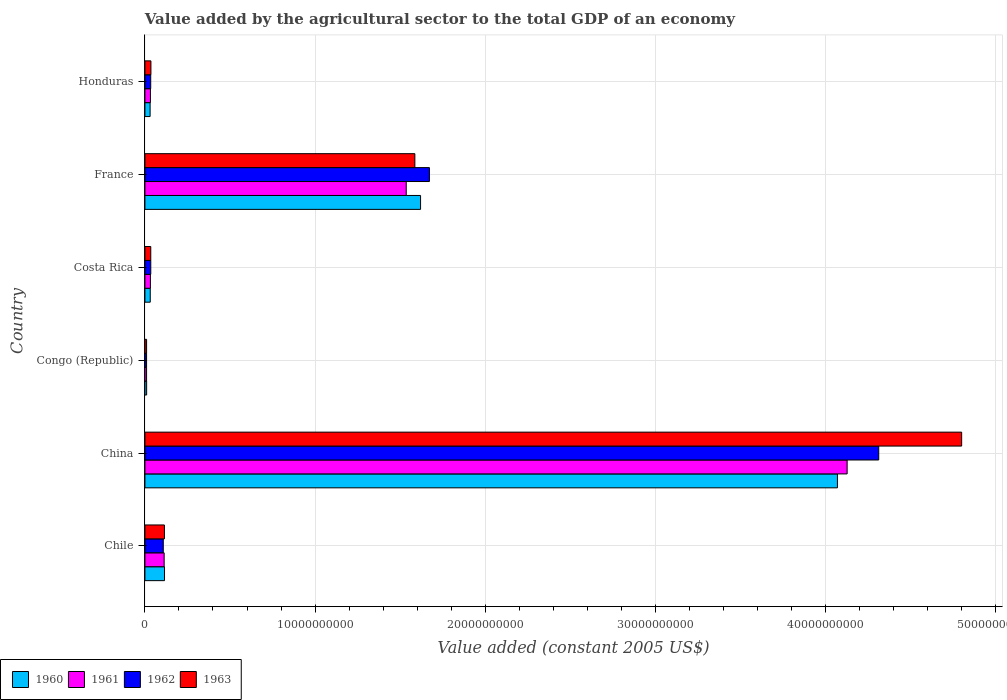How many different coloured bars are there?
Provide a succinct answer. 4. Are the number of bars per tick equal to the number of legend labels?
Offer a terse response. Yes. What is the label of the 5th group of bars from the top?
Your answer should be compact. China. In how many cases, is the number of bars for a given country not equal to the number of legend labels?
Offer a terse response. 0. What is the value added by the agricultural sector in 1963 in Congo (Republic)?
Ensure brevity in your answer.  9.86e+07. Across all countries, what is the maximum value added by the agricultural sector in 1963?
Provide a succinct answer. 4.80e+1. Across all countries, what is the minimum value added by the agricultural sector in 1961?
Your answer should be very brief. 9.74e+07. In which country was the value added by the agricultural sector in 1963 maximum?
Ensure brevity in your answer.  China. In which country was the value added by the agricultural sector in 1963 minimum?
Make the answer very short. Congo (Republic). What is the total value added by the agricultural sector in 1962 in the graph?
Give a very brief answer. 6.17e+1. What is the difference between the value added by the agricultural sector in 1963 in Chile and that in France?
Give a very brief answer. -1.47e+1. What is the difference between the value added by the agricultural sector in 1963 in France and the value added by the agricultural sector in 1962 in Honduras?
Provide a succinct answer. 1.55e+1. What is the average value added by the agricultural sector in 1963 per country?
Provide a short and direct response. 1.10e+1. What is the difference between the value added by the agricultural sector in 1961 and value added by the agricultural sector in 1960 in Costa Rica?
Provide a short and direct response. 1.15e+07. In how many countries, is the value added by the agricultural sector in 1960 greater than 26000000000 US$?
Offer a terse response. 1. What is the ratio of the value added by the agricultural sector in 1963 in Costa Rica to that in France?
Ensure brevity in your answer.  0.02. Is the difference between the value added by the agricultural sector in 1961 in Costa Rica and Honduras greater than the difference between the value added by the agricultural sector in 1960 in Costa Rica and Honduras?
Provide a short and direct response. No. What is the difference between the highest and the second highest value added by the agricultural sector in 1962?
Provide a short and direct response. 2.64e+1. What is the difference between the highest and the lowest value added by the agricultural sector in 1961?
Provide a short and direct response. 4.12e+1. Is the sum of the value added by the agricultural sector in 1962 in China and Congo (Republic) greater than the maximum value added by the agricultural sector in 1963 across all countries?
Offer a terse response. No. Are all the bars in the graph horizontal?
Ensure brevity in your answer.  Yes. How many countries are there in the graph?
Ensure brevity in your answer.  6. How many legend labels are there?
Make the answer very short. 4. What is the title of the graph?
Your answer should be compact. Value added by the agricultural sector to the total GDP of an economy. Does "1986" appear as one of the legend labels in the graph?
Provide a short and direct response. No. What is the label or title of the X-axis?
Keep it short and to the point. Value added (constant 2005 US$). What is the Value added (constant 2005 US$) of 1960 in Chile?
Offer a very short reply. 1.15e+09. What is the Value added (constant 2005 US$) of 1961 in Chile?
Provide a short and direct response. 1.13e+09. What is the Value added (constant 2005 US$) in 1962 in Chile?
Give a very brief answer. 1.08e+09. What is the Value added (constant 2005 US$) in 1963 in Chile?
Give a very brief answer. 1.15e+09. What is the Value added (constant 2005 US$) of 1960 in China?
Your response must be concise. 4.07e+1. What is the Value added (constant 2005 US$) of 1961 in China?
Offer a terse response. 4.13e+1. What is the Value added (constant 2005 US$) of 1962 in China?
Offer a terse response. 4.31e+1. What is the Value added (constant 2005 US$) of 1963 in China?
Give a very brief answer. 4.80e+1. What is the Value added (constant 2005 US$) in 1960 in Congo (Republic)?
Make the answer very short. 1.01e+08. What is the Value added (constant 2005 US$) of 1961 in Congo (Republic)?
Offer a terse response. 9.74e+07. What is the Value added (constant 2005 US$) of 1962 in Congo (Republic)?
Offer a terse response. 9.79e+07. What is the Value added (constant 2005 US$) in 1963 in Congo (Republic)?
Offer a very short reply. 9.86e+07. What is the Value added (constant 2005 US$) in 1960 in Costa Rica?
Make the answer very short. 3.13e+08. What is the Value added (constant 2005 US$) of 1961 in Costa Rica?
Offer a very short reply. 3.24e+08. What is the Value added (constant 2005 US$) of 1962 in Costa Rica?
Your answer should be very brief. 3.44e+08. What is the Value added (constant 2005 US$) of 1963 in Costa Rica?
Give a very brief answer. 3.43e+08. What is the Value added (constant 2005 US$) in 1960 in France?
Ensure brevity in your answer.  1.62e+1. What is the Value added (constant 2005 US$) in 1961 in France?
Offer a terse response. 1.54e+1. What is the Value added (constant 2005 US$) in 1962 in France?
Give a very brief answer. 1.67e+1. What is the Value added (constant 2005 US$) of 1963 in France?
Your answer should be compact. 1.59e+1. What is the Value added (constant 2005 US$) of 1960 in Honduras?
Provide a short and direct response. 3.05e+08. What is the Value added (constant 2005 US$) in 1961 in Honduras?
Provide a short and direct response. 3.25e+08. What is the Value added (constant 2005 US$) in 1962 in Honduras?
Provide a succinct answer. 3.41e+08. What is the Value added (constant 2005 US$) of 1963 in Honduras?
Keep it short and to the point. 3.53e+08. Across all countries, what is the maximum Value added (constant 2005 US$) of 1960?
Your answer should be compact. 4.07e+1. Across all countries, what is the maximum Value added (constant 2005 US$) of 1961?
Keep it short and to the point. 4.13e+1. Across all countries, what is the maximum Value added (constant 2005 US$) in 1962?
Provide a succinct answer. 4.31e+1. Across all countries, what is the maximum Value added (constant 2005 US$) of 1963?
Provide a succinct answer. 4.80e+1. Across all countries, what is the minimum Value added (constant 2005 US$) in 1960?
Your response must be concise. 1.01e+08. Across all countries, what is the minimum Value added (constant 2005 US$) in 1961?
Your answer should be very brief. 9.74e+07. Across all countries, what is the minimum Value added (constant 2005 US$) in 1962?
Your response must be concise. 9.79e+07. Across all countries, what is the minimum Value added (constant 2005 US$) in 1963?
Your answer should be very brief. 9.86e+07. What is the total Value added (constant 2005 US$) in 1960 in the graph?
Provide a short and direct response. 5.88e+1. What is the total Value added (constant 2005 US$) of 1961 in the graph?
Your answer should be very brief. 5.85e+1. What is the total Value added (constant 2005 US$) of 1962 in the graph?
Ensure brevity in your answer.  6.17e+1. What is the total Value added (constant 2005 US$) in 1963 in the graph?
Ensure brevity in your answer.  6.58e+1. What is the difference between the Value added (constant 2005 US$) in 1960 in Chile and that in China?
Provide a succinct answer. -3.95e+1. What is the difference between the Value added (constant 2005 US$) of 1961 in Chile and that in China?
Your answer should be very brief. -4.01e+1. What is the difference between the Value added (constant 2005 US$) in 1962 in Chile and that in China?
Your answer should be very brief. -4.20e+1. What is the difference between the Value added (constant 2005 US$) in 1963 in Chile and that in China?
Provide a short and direct response. -4.69e+1. What is the difference between the Value added (constant 2005 US$) of 1960 in Chile and that in Congo (Republic)?
Your response must be concise. 1.05e+09. What is the difference between the Value added (constant 2005 US$) of 1961 in Chile and that in Congo (Republic)?
Keep it short and to the point. 1.03e+09. What is the difference between the Value added (constant 2005 US$) of 1962 in Chile and that in Congo (Republic)?
Offer a terse response. 9.81e+08. What is the difference between the Value added (constant 2005 US$) of 1963 in Chile and that in Congo (Republic)?
Give a very brief answer. 1.05e+09. What is the difference between the Value added (constant 2005 US$) in 1960 in Chile and that in Costa Rica?
Offer a very short reply. 8.39e+08. What is the difference between the Value added (constant 2005 US$) of 1961 in Chile and that in Costa Rica?
Ensure brevity in your answer.  8.06e+08. What is the difference between the Value added (constant 2005 US$) in 1962 in Chile and that in Costa Rica?
Provide a succinct answer. 7.35e+08. What is the difference between the Value added (constant 2005 US$) of 1963 in Chile and that in Costa Rica?
Your answer should be compact. 8.03e+08. What is the difference between the Value added (constant 2005 US$) of 1960 in Chile and that in France?
Keep it short and to the point. -1.50e+1. What is the difference between the Value added (constant 2005 US$) in 1961 in Chile and that in France?
Give a very brief answer. -1.42e+1. What is the difference between the Value added (constant 2005 US$) in 1962 in Chile and that in France?
Your answer should be compact. -1.56e+1. What is the difference between the Value added (constant 2005 US$) of 1963 in Chile and that in France?
Provide a short and direct response. -1.47e+1. What is the difference between the Value added (constant 2005 US$) of 1960 in Chile and that in Honduras?
Provide a short and direct response. 8.46e+08. What is the difference between the Value added (constant 2005 US$) in 1961 in Chile and that in Honduras?
Provide a succinct answer. 8.05e+08. What is the difference between the Value added (constant 2005 US$) in 1962 in Chile and that in Honduras?
Give a very brief answer. 7.38e+08. What is the difference between the Value added (constant 2005 US$) in 1963 in Chile and that in Honduras?
Offer a terse response. 7.93e+08. What is the difference between the Value added (constant 2005 US$) in 1960 in China and that in Congo (Republic)?
Give a very brief answer. 4.06e+1. What is the difference between the Value added (constant 2005 US$) in 1961 in China and that in Congo (Republic)?
Give a very brief answer. 4.12e+1. What is the difference between the Value added (constant 2005 US$) in 1962 in China and that in Congo (Republic)?
Offer a very short reply. 4.30e+1. What is the difference between the Value added (constant 2005 US$) of 1963 in China and that in Congo (Republic)?
Provide a short and direct response. 4.79e+1. What is the difference between the Value added (constant 2005 US$) of 1960 in China and that in Costa Rica?
Provide a succinct answer. 4.04e+1. What is the difference between the Value added (constant 2005 US$) in 1961 in China and that in Costa Rica?
Provide a succinct answer. 4.09e+1. What is the difference between the Value added (constant 2005 US$) of 1962 in China and that in Costa Rica?
Ensure brevity in your answer.  4.28e+1. What is the difference between the Value added (constant 2005 US$) in 1963 in China and that in Costa Rica?
Ensure brevity in your answer.  4.77e+1. What is the difference between the Value added (constant 2005 US$) of 1960 in China and that in France?
Provide a short and direct response. 2.45e+1. What is the difference between the Value added (constant 2005 US$) in 1961 in China and that in France?
Give a very brief answer. 2.59e+1. What is the difference between the Value added (constant 2005 US$) in 1962 in China and that in France?
Provide a succinct answer. 2.64e+1. What is the difference between the Value added (constant 2005 US$) in 1963 in China and that in France?
Offer a very short reply. 3.21e+1. What is the difference between the Value added (constant 2005 US$) in 1960 in China and that in Honduras?
Keep it short and to the point. 4.04e+1. What is the difference between the Value added (constant 2005 US$) of 1961 in China and that in Honduras?
Ensure brevity in your answer.  4.09e+1. What is the difference between the Value added (constant 2005 US$) of 1962 in China and that in Honduras?
Provide a short and direct response. 4.28e+1. What is the difference between the Value added (constant 2005 US$) in 1963 in China and that in Honduras?
Your response must be concise. 4.76e+1. What is the difference between the Value added (constant 2005 US$) of 1960 in Congo (Republic) and that in Costa Rica?
Your answer should be very brief. -2.12e+08. What is the difference between the Value added (constant 2005 US$) in 1961 in Congo (Republic) and that in Costa Rica?
Ensure brevity in your answer.  -2.27e+08. What is the difference between the Value added (constant 2005 US$) of 1962 in Congo (Republic) and that in Costa Rica?
Your answer should be compact. -2.46e+08. What is the difference between the Value added (constant 2005 US$) in 1963 in Congo (Republic) and that in Costa Rica?
Ensure brevity in your answer.  -2.45e+08. What is the difference between the Value added (constant 2005 US$) in 1960 in Congo (Republic) and that in France?
Offer a very short reply. -1.61e+1. What is the difference between the Value added (constant 2005 US$) in 1961 in Congo (Republic) and that in France?
Give a very brief answer. -1.53e+1. What is the difference between the Value added (constant 2005 US$) of 1962 in Congo (Republic) and that in France?
Keep it short and to the point. -1.66e+1. What is the difference between the Value added (constant 2005 US$) of 1963 in Congo (Republic) and that in France?
Your answer should be compact. -1.58e+1. What is the difference between the Value added (constant 2005 US$) in 1960 in Congo (Republic) and that in Honduras?
Your answer should be compact. -2.04e+08. What is the difference between the Value added (constant 2005 US$) in 1961 in Congo (Republic) and that in Honduras?
Your answer should be compact. -2.28e+08. What is the difference between the Value added (constant 2005 US$) in 1962 in Congo (Republic) and that in Honduras?
Give a very brief answer. -2.43e+08. What is the difference between the Value added (constant 2005 US$) of 1963 in Congo (Republic) and that in Honduras?
Keep it short and to the point. -2.55e+08. What is the difference between the Value added (constant 2005 US$) of 1960 in Costa Rica and that in France?
Your response must be concise. -1.59e+1. What is the difference between the Value added (constant 2005 US$) of 1961 in Costa Rica and that in France?
Provide a succinct answer. -1.50e+1. What is the difference between the Value added (constant 2005 US$) of 1962 in Costa Rica and that in France?
Your response must be concise. -1.64e+1. What is the difference between the Value added (constant 2005 US$) in 1963 in Costa Rica and that in France?
Provide a short and direct response. -1.55e+1. What is the difference between the Value added (constant 2005 US$) of 1960 in Costa Rica and that in Honduras?
Provide a short and direct response. 7.61e+06. What is the difference between the Value added (constant 2005 US$) in 1961 in Costa Rica and that in Honduras?
Your answer should be compact. -8.14e+05. What is the difference between the Value added (constant 2005 US$) in 1962 in Costa Rica and that in Honduras?
Your answer should be compact. 3.61e+06. What is the difference between the Value added (constant 2005 US$) in 1963 in Costa Rica and that in Honduras?
Your answer should be compact. -9.78e+06. What is the difference between the Value added (constant 2005 US$) in 1960 in France and that in Honduras?
Your answer should be compact. 1.59e+1. What is the difference between the Value added (constant 2005 US$) of 1961 in France and that in Honduras?
Your answer should be compact. 1.50e+1. What is the difference between the Value added (constant 2005 US$) of 1962 in France and that in Honduras?
Offer a very short reply. 1.64e+1. What is the difference between the Value added (constant 2005 US$) in 1963 in France and that in Honduras?
Your response must be concise. 1.55e+1. What is the difference between the Value added (constant 2005 US$) in 1960 in Chile and the Value added (constant 2005 US$) in 1961 in China?
Offer a very short reply. -4.01e+1. What is the difference between the Value added (constant 2005 US$) in 1960 in Chile and the Value added (constant 2005 US$) in 1962 in China?
Keep it short and to the point. -4.20e+1. What is the difference between the Value added (constant 2005 US$) in 1960 in Chile and the Value added (constant 2005 US$) in 1963 in China?
Keep it short and to the point. -4.68e+1. What is the difference between the Value added (constant 2005 US$) of 1961 in Chile and the Value added (constant 2005 US$) of 1962 in China?
Offer a terse response. -4.20e+1. What is the difference between the Value added (constant 2005 US$) in 1961 in Chile and the Value added (constant 2005 US$) in 1963 in China?
Offer a terse response. -4.69e+1. What is the difference between the Value added (constant 2005 US$) of 1962 in Chile and the Value added (constant 2005 US$) of 1963 in China?
Your answer should be very brief. -4.69e+1. What is the difference between the Value added (constant 2005 US$) in 1960 in Chile and the Value added (constant 2005 US$) in 1961 in Congo (Republic)?
Provide a succinct answer. 1.05e+09. What is the difference between the Value added (constant 2005 US$) of 1960 in Chile and the Value added (constant 2005 US$) of 1962 in Congo (Republic)?
Make the answer very short. 1.05e+09. What is the difference between the Value added (constant 2005 US$) of 1960 in Chile and the Value added (constant 2005 US$) of 1963 in Congo (Republic)?
Provide a succinct answer. 1.05e+09. What is the difference between the Value added (constant 2005 US$) of 1961 in Chile and the Value added (constant 2005 US$) of 1962 in Congo (Republic)?
Your answer should be compact. 1.03e+09. What is the difference between the Value added (constant 2005 US$) in 1961 in Chile and the Value added (constant 2005 US$) in 1963 in Congo (Republic)?
Your response must be concise. 1.03e+09. What is the difference between the Value added (constant 2005 US$) in 1962 in Chile and the Value added (constant 2005 US$) in 1963 in Congo (Republic)?
Your answer should be very brief. 9.81e+08. What is the difference between the Value added (constant 2005 US$) of 1960 in Chile and the Value added (constant 2005 US$) of 1961 in Costa Rica?
Give a very brief answer. 8.27e+08. What is the difference between the Value added (constant 2005 US$) of 1960 in Chile and the Value added (constant 2005 US$) of 1962 in Costa Rica?
Your answer should be compact. 8.07e+08. What is the difference between the Value added (constant 2005 US$) of 1960 in Chile and the Value added (constant 2005 US$) of 1963 in Costa Rica?
Keep it short and to the point. 8.08e+08. What is the difference between the Value added (constant 2005 US$) in 1961 in Chile and the Value added (constant 2005 US$) in 1962 in Costa Rica?
Keep it short and to the point. 7.86e+08. What is the difference between the Value added (constant 2005 US$) in 1961 in Chile and the Value added (constant 2005 US$) in 1963 in Costa Rica?
Provide a succinct answer. 7.87e+08. What is the difference between the Value added (constant 2005 US$) in 1962 in Chile and the Value added (constant 2005 US$) in 1963 in Costa Rica?
Give a very brief answer. 7.36e+08. What is the difference between the Value added (constant 2005 US$) of 1960 in Chile and the Value added (constant 2005 US$) of 1961 in France?
Your answer should be compact. -1.42e+1. What is the difference between the Value added (constant 2005 US$) of 1960 in Chile and the Value added (constant 2005 US$) of 1962 in France?
Provide a succinct answer. -1.56e+1. What is the difference between the Value added (constant 2005 US$) of 1960 in Chile and the Value added (constant 2005 US$) of 1963 in France?
Make the answer very short. -1.47e+1. What is the difference between the Value added (constant 2005 US$) in 1961 in Chile and the Value added (constant 2005 US$) in 1962 in France?
Make the answer very short. -1.56e+1. What is the difference between the Value added (constant 2005 US$) in 1961 in Chile and the Value added (constant 2005 US$) in 1963 in France?
Your answer should be compact. -1.47e+1. What is the difference between the Value added (constant 2005 US$) in 1962 in Chile and the Value added (constant 2005 US$) in 1963 in France?
Your answer should be very brief. -1.48e+1. What is the difference between the Value added (constant 2005 US$) in 1960 in Chile and the Value added (constant 2005 US$) in 1961 in Honduras?
Offer a very short reply. 8.27e+08. What is the difference between the Value added (constant 2005 US$) of 1960 in Chile and the Value added (constant 2005 US$) of 1962 in Honduras?
Your answer should be compact. 8.11e+08. What is the difference between the Value added (constant 2005 US$) in 1960 in Chile and the Value added (constant 2005 US$) in 1963 in Honduras?
Make the answer very short. 7.99e+08. What is the difference between the Value added (constant 2005 US$) of 1961 in Chile and the Value added (constant 2005 US$) of 1962 in Honduras?
Ensure brevity in your answer.  7.90e+08. What is the difference between the Value added (constant 2005 US$) of 1961 in Chile and the Value added (constant 2005 US$) of 1963 in Honduras?
Offer a very short reply. 7.78e+08. What is the difference between the Value added (constant 2005 US$) of 1962 in Chile and the Value added (constant 2005 US$) of 1963 in Honduras?
Keep it short and to the point. 7.26e+08. What is the difference between the Value added (constant 2005 US$) of 1960 in China and the Value added (constant 2005 US$) of 1961 in Congo (Republic)?
Keep it short and to the point. 4.06e+1. What is the difference between the Value added (constant 2005 US$) in 1960 in China and the Value added (constant 2005 US$) in 1962 in Congo (Republic)?
Your answer should be compact. 4.06e+1. What is the difference between the Value added (constant 2005 US$) in 1960 in China and the Value added (constant 2005 US$) in 1963 in Congo (Republic)?
Keep it short and to the point. 4.06e+1. What is the difference between the Value added (constant 2005 US$) of 1961 in China and the Value added (constant 2005 US$) of 1962 in Congo (Republic)?
Offer a very short reply. 4.12e+1. What is the difference between the Value added (constant 2005 US$) in 1961 in China and the Value added (constant 2005 US$) in 1963 in Congo (Republic)?
Give a very brief answer. 4.12e+1. What is the difference between the Value added (constant 2005 US$) in 1962 in China and the Value added (constant 2005 US$) in 1963 in Congo (Republic)?
Ensure brevity in your answer.  4.30e+1. What is the difference between the Value added (constant 2005 US$) of 1960 in China and the Value added (constant 2005 US$) of 1961 in Costa Rica?
Your answer should be very brief. 4.04e+1. What is the difference between the Value added (constant 2005 US$) in 1960 in China and the Value added (constant 2005 US$) in 1962 in Costa Rica?
Ensure brevity in your answer.  4.04e+1. What is the difference between the Value added (constant 2005 US$) of 1960 in China and the Value added (constant 2005 US$) of 1963 in Costa Rica?
Your answer should be very brief. 4.04e+1. What is the difference between the Value added (constant 2005 US$) of 1961 in China and the Value added (constant 2005 US$) of 1962 in Costa Rica?
Ensure brevity in your answer.  4.09e+1. What is the difference between the Value added (constant 2005 US$) in 1961 in China and the Value added (constant 2005 US$) in 1963 in Costa Rica?
Your answer should be very brief. 4.09e+1. What is the difference between the Value added (constant 2005 US$) in 1962 in China and the Value added (constant 2005 US$) in 1963 in Costa Rica?
Offer a terse response. 4.28e+1. What is the difference between the Value added (constant 2005 US$) of 1960 in China and the Value added (constant 2005 US$) of 1961 in France?
Your answer should be very brief. 2.53e+1. What is the difference between the Value added (constant 2005 US$) of 1960 in China and the Value added (constant 2005 US$) of 1962 in France?
Keep it short and to the point. 2.40e+1. What is the difference between the Value added (constant 2005 US$) in 1960 in China and the Value added (constant 2005 US$) in 1963 in France?
Offer a very short reply. 2.48e+1. What is the difference between the Value added (constant 2005 US$) of 1961 in China and the Value added (constant 2005 US$) of 1962 in France?
Make the answer very short. 2.45e+1. What is the difference between the Value added (constant 2005 US$) of 1961 in China and the Value added (constant 2005 US$) of 1963 in France?
Keep it short and to the point. 2.54e+1. What is the difference between the Value added (constant 2005 US$) in 1962 in China and the Value added (constant 2005 US$) in 1963 in France?
Make the answer very short. 2.73e+1. What is the difference between the Value added (constant 2005 US$) in 1960 in China and the Value added (constant 2005 US$) in 1961 in Honduras?
Your response must be concise. 4.04e+1. What is the difference between the Value added (constant 2005 US$) of 1960 in China and the Value added (constant 2005 US$) of 1962 in Honduras?
Your response must be concise. 4.04e+1. What is the difference between the Value added (constant 2005 US$) in 1960 in China and the Value added (constant 2005 US$) in 1963 in Honduras?
Your response must be concise. 4.03e+1. What is the difference between the Value added (constant 2005 US$) of 1961 in China and the Value added (constant 2005 US$) of 1962 in Honduras?
Make the answer very short. 4.09e+1. What is the difference between the Value added (constant 2005 US$) of 1961 in China and the Value added (constant 2005 US$) of 1963 in Honduras?
Provide a short and direct response. 4.09e+1. What is the difference between the Value added (constant 2005 US$) in 1962 in China and the Value added (constant 2005 US$) in 1963 in Honduras?
Your response must be concise. 4.28e+1. What is the difference between the Value added (constant 2005 US$) in 1960 in Congo (Republic) and the Value added (constant 2005 US$) in 1961 in Costa Rica?
Provide a short and direct response. -2.24e+08. What is the difference between the Value added (constant 2005 US$) in 1960 in Congo (Republic) and the Value added (constant 2005 US$) in 1962 in Costa Rica?
Your answer should be compact. -2.43e+08. What is the difference between the Value added (constant 2005 US$) of 1960 in Congo (Republic) and the Value added (constant 2005 US$) of 1963 in Costa Rica?
Your response must be concise. -2.42e+08. What is the difference between the Value added (constant 2005 US$) in 1961 in Congo (Republic) and the Value added (constant 2005 US$) in 1962 in Costa Rica?
Keep it short and to the point. -2.47e+08. What is the difference between the Value added (constant 2005 US$) of 1961 in Congo (Republic) and the Value added (constant 2005 US$) of 1963 in Costa Rica?
Your answer should be compact. -2.46e+08. What is the difference between the Value added (constant 2005 US$) of 1962 in Congo (Republic) and the Value added (constant 2005 US$) of 1963 in Costa Rica?
Provide a succinct answer. -2.45e+08. What is the difference between the Value added (constant 2005 US$) of 1960 in Congo (Republic) and the Value added (constant 2005 US$) of 1961 in France?
Make the answer very short. -1.53e+1. What is the difference between the Value added (constant 2005 US$) of 1960 in Congo (Republic) and the Value added (constant 2005 US$) of 1962 in France?
Your response must be concise. -1.66e+1. What is the difference between the Value added (constant 2005 US$) of 1960 in Congo (Republic) and the Value added (constant 2005 US$) of 1963 in France?
Provide a succinct answer. -1.58e+1. What is the difference between the Value added (constant 2005 US$) of 1961 in Congo (Republic) and the Value added (constant 2005 US$) of 1962 in France?
Keep it short and to the point. -1.66e+1. What is the difference between the Value added (constant 2005 US$) of 1961 in Congo (Republic) and the Value added (constant 2005 US$) of 1963 in France?
Provide a short and direct response. -1.58e+1. What is the difference between the Value added (constant 2005 US$) of 1962 in Congo (Republic) and the Value added (constant 2005 US$) of 1963 in France?
Give a very brief answer. -1.58e+1. What is the difference between the Value added (constant 2005 US$) in 1960 in Congo (Republic) and the Value added (constant 2005 US$) in 1961 in Honduras?
Provide a short and direct response. -2.24e+08. What is the difference between the Value added (constant 2005 US$) in 1960 in Congo (Republic) and the Value added (constant 2005 US$) in 1962 in Honduras?
Give a very brief answer. -2.40e+08. What is the difference between the Value added (constant 2005 US$) of 1960 in Congo (Republic) and the Value added (constant 2005 US$) of 1963 in Honduras?
Keep it short and to the point. -2.52e+08. What is the difference between the Value added (constant 2005 US$) in 1961 in Congo (Republic) and the Value added (constant 2005 US$) in 1962 in Honduras?
Provide a short and direct response. -2.43e+08. What is the difference between the Value added (constant 2005 US$) of 1961 in Congo (Republic) and the Value added (constant 2005 US$) of 1963 in Honduras?
Your answer should be compact. -2.56e+08. What is the difference between the Value added (constant 2005 US$) in 1962 in Congo (Republic) and the Value added (constant 2005 US$) in 1963 in Honduras?
Your answer should be very brief. -2.55e+08. What is the difference between the Value added (constant 2005 US$) in 1960 in Costa Rica and the Value added (constant 2005 US$) in 1961 in France?
Ensure brevity in your answer.  -1.50e+1. What is the difference between the Value added (constant 2005 US$) of 1960 in Costa Rica and the Value added (constant 2005 US$) of 1962 in France?
Your answer should be compact. -1.64e+1. What is the difference between the Value added (constant 2005 US$) of 1960 in Costa Rica and the Value added (constant 2005 US$) of 1963 in France?
Your answer should be very brief. -1.56e+1. What is the difference between the Value added (constant 2005 US$) in 1961 in Costa Rica and the Value added (constant 2005 US$) in 1962 in France?
Give a very brief answer. -1.64e+1. What is the difference between the Value added (constant 2005 US$) of 1961 in Costa Rica and the Value added (constant 2005 US$) of 1963 in France?
Offer a terse response. -1.55e+1. What is the difference between the Value added (constant 2005 US$) of 1962 in Costa Rica and the Value added (constant 2005 US$) of 1963 in France?
Provide a short and direct response. -1.55e+1. What is the difference between the Value added (constant 2005 US$) in 1960 in Costa Rica and the Value added (constant 2005 US$) in 1961 in Honduras?
Provide a short and direct response. -1.23e+07. What is the difference between the Value added (constant 2005 US$) of 1960 in Costa Rica and the Value added (constant 2005 US$) of 1962 in Honduras?
Give a very brief answer. -2.78e+07. What is the difference between the Value added (constant 2005 US$) in 1960 in Costa Rica and the Value added (constant 2005 US$) in 1963 in Honduras?
Give a very brief answer. -4.02e+07. What is the difference between the Value added (constant 2005 US$) of 1961 in Costa Rica and the Value added (constant 2005 US$) of 1962 in Honduras?
Give a very brief answer. -1.63e+07. What is the difference between the Value added (constant 2005 US$) of 1961 in Costa Rica and the Value added (constant 2005 US$) of 1963 in Honduras?
Provide a succinct answer. -2.87e+07. What is the difference between the Value added (constant 2005 US$) in 1962 in Costa Rica and the Value added (constant 2005 US$) in 1963 in Honduras?
Give a very brief answer. -8.78e+06. What is the difference between the Value added (constant 2005 US$) of 1960 in France and the Value added (constant 2005 US$) of 1961 in Honduras?
Your answer should be very brief. 1.59e+1. What is the difference between the Value added (constant 2005 US$) of 1960 in France and the Value added (constant 2005 US$) of 1962 in Honduras?
Offer a terse response. 1.59e+1. What is the difference between the Value added (constant 2005 US$) in 1960 in France and the Value added (constant 2005 US$) in 1963 in Honduras?
Give a very brief answer. 1.58e+1. What is the difference between the Value added (constant 2005 US$) in 1961 in France and the Value added (constant 2005 US$) in 1962 in Honduras?
Provide a succinct answer. 1.50e+1. What is the difference between the Value added (constant 2005 US$) in 1961 in France and the Value added (constant 2005 US$) in 1963 in Honduras?
Offer a terse response. 1.50e+1. What is the difference between the Value added (constant 2005 US$) in 1962 in France and the Value added (constant 2005 US$) in 1963 in Honduras?
Your response must be concise. 1.64e+1. What is the average Value added (constant 2005 US$) in 1960 per country?
Provide a short and direct response. 9.79e+09. What is the average Value added (constant 2005 US$) of 1961 per country?
Make the answer very short. 9.75e+09. What is the average Value added (constant 2005 US$) in 1962 per country?
Offer a very short reply. 1.03e+1. What is the average Value added (constant 2005 US$) of 1963 per country?
Provide a short and direct response. 1.10e+1. What is the difference between the Value added (constant 2005 US$) in 1960 and Value added (constant 2005 US$) in 1961 in Chile?
Your answer should be very brief. 2.12e+07. What is the difference between the Value added (constant 2005 US$) of 1960 and Value added (constant 2005 US$) of 1962 in Chile?
Offer a very short reply. 7.27e+07. What is the difference between the Value added (constant 2005 US$) in 1960 and Value added (constant 2005 US$) in 1963 in Chile?
Give a very brief answer. 5.74e+06. What is the difference between the Value added (constant 2005 US$) of 1961 and Value added (constant 2005 US$) of 1962 in Chile?
Give a very brief answer. 5.15e+07. What is the difference between the Value added (constant 2005 US$) of 1961 and Value added (constant 2005 US$) of 1963 in Chile?
Offer a terse response. -1.54e+07. What is the difference between the Value added (constant 2005 US$) in 1962 and Value added (constant 2005 US$) in 1963 in Chile?
Keep it short and to the point. -6.69e+07. What is the difference between the Value added (constant 2005 US$) in 1960 and Value added (constant 2005 US$) in 1961 in China?
Provide a succinct answer. -5.70e+08. What is the difference between the Value added (constant 2005 US$) in 1960 and Value added (constant 2005 US$) in 1962 in China?
Provide a succinct answer. -2.43e+09. What is the difference between the Value added (constant 2005 US$) in 1960 and Value added (constant 2005 US$) in 1963 in China?
Offer a terse response. -7.30e+09. What is the difference between the Value added (constant 2005 US$) of 1961 and Value added (constant 2005 US$) of 1962 in China?
Your response must be concise. -1.86e+09. What is the difference between the Value added (constant 2005 US$) of 1961 and Value added (constant 2005 US$) of 1963 in China?
Provide a short and direct response. -6.73e+09. What is the difference between the Value added (constant 2005 US$) in 1962 and Value added (constant 2005 US$) in 1963 in China?
Provide a short and direct response. -4.87e+09. What is the difference between the Value added (constant 2005 US$) of 1960 and Value added (constant 2005 US$) of 1961 in Congo (Republic)?
Your answer should be very brief. 3.61e+06. What is the difference between the Value added (constant 2005 US$) of 1960 and Value added (constant 2005 US$) of 1962 in Congo (Republic)?
Provide a succinct answer. 3.02e+06. What is the difference between the Value added (constant 2005 US$) of 1960 and Value added (constant 2005 US$) of 1963 in Congo (Republic)?
Provide a succinct answer. 2.34e+06. What is the difference between the Value added (constant 2005 US$) in 1961 and Value added (constant 2005 US$) in 1962 in Congo (Republic)?
Offer a very short reply. -5.86e+05. What is the difference between the Value added (constant 2005 US$) of 1961 and Value added (constant 2005 US$) of 1963 in Congo (Republic)?
Your answer should be compact. -1.27e+06. What is the difference between the Value added (constant 2005 US$) of 1962 and Value added (constant 2005 US$) of 1963 in Congo (Republic)?
Keep it short and to the point. -6.85e+05. What is the difference between the Value added (constant 2005 US$) of 1960 and Value added (constant 2005 US$) of 1961 in Costa Rica?
Provide a short and direct response. -1.15e+07. What is the difference between the Value added (constant 2005 US$) of 1960 and Value added (constant 2005 US$) of 1962 in Costa Rica?
Offer a very short reply. -3.14e+07. What is the difference between the Value added (constant 2005 US$) of 1960 and Value added (constant 2005 US$) of 1963 in Costa Rica?
Provide a succinct answer. -3.04e+07. What is the difference between the Value added (constant 2005 US$) of 1961 and Value added (constant 2005 US$) of 1962 in Costa Rica?
Provide a succinct answer. -1.99e+07. What is the difference between the Value added (constant 2005 US$) in 1961 and Value added (constant 2005 US$) in 1963 in Costa Rica?
Provide a short and direct response. -1.89e+07. What is the difference between the Value added (constant 2005 US$) in 1962 and Value added (constant 2005 US$) in 1963 in Costa Rica?
Your response must be concise. 1.00e+06. What is the difference between the Value added (constant 2005 US$) of 1960 and Value added (constant 2005 US$) of 1961 in France?
Ensure brevity in your answer.  8.42e+08. What is the difference between the Value added (constant 2005 US$) of 1960 and Value added (constant 2005 US$) of 1962 in France?
Ensure brevity in your answer.  -5.20e+08. What is the difference between the Value added (constant 2005 US$) of 1960 and Value added (constant 2005 US$) of 1963 in France?
Give a very brief answer. 3.35e+08. What is the difference between the Value added (constant 2005 US$) of 1961 and Value added (constant 2005 US$) of 1962 in France?
Offer a very short reply. -1.36e+09. What is the difference between the Value added (constant 2005 US$) of 1961 and Value added (constant 2005 US$) of 1963 in France?
Your response must be concise. -5.07e+08. What is the difference between the Value added (constant 2005 US$) in 1962 and Value added (constant 2005 US$) in 1963 in France?
Your response must be concise. 8.56e+08. What is the difference between the Value added (constant 2005 US$) in 1960 and Value added (constant 2005 US$) in 1961 in Honduras?
Offer a very short reply. -1.99e+07. What is the difference between the Value added (constant 2005 US$) of 1960 and Value added (constant 2005 US$) of 1962 in Honduras?
Make the answer very short. -3.54e+07. What is the difference between the Value added (constant 2005 US$) in 1960 and Value added (constant 2005 US$) in 1963 in Honduras?
Ensure brevity in your answer.  -4.78e+07. What is the difference between the Value added (constant 2005 US$) of 1961 and Value added (constant 2005 US$) of 1962 in Honduras?
Provide a succinct answer. -1.55e+07. What is the difference between the Value added (constant 2005 US$) in 1961 and Value added (constant 2005 US$) in 1963 in Honduras?
Your answer should be compact. -2.79e+07. What is the difference between the Value added (constant 2005 US$) of 1962 and Value added (constant 2005 US$) of 1963 in Honduras?
Your response must be concise. -1.24e+07. What is the ratio of the Value added (constant 2005 US$) in 1960 in Chile to that in China?
Keep it short and to the point. 0.03. What is the ratio of the Value added (constant 2005 US$) in 1961 in Chile to that in China?
Your response must be concise. 0.03. What is the ratio of the Value added (constant 2005 US$) in 1962 in Chile to that in China?
Offer a terse response. 0.03. What is the ratio of the Value added (constant 2005 US$) of 1963 in Chile to that in China?
Give a very brief answer. 0.02. What is the ratio of the Value added (constant 2005 US$) of 1960 in Chile to that in Congo (Republic)?
Your answer should be compact. 11.41. What is the ratio of the Value added (constant 2005 US$) of 1961 in Chile to that in Congo (Republic)?
Give a very brief answer. 11.61. What is the ratio of the Value added (constant 2005 US$) of 1962 in Chile to that in Congo (Republic)?
Provide a short and direct response. 11.02. What is the ratio of the Value added (constant 2005 US$) in 1963 in Chile to that in Congo (Republic)?
Keep it short and to the point. 11.62. What is the ratio of the Value added (constant 2005 US$) of 1960 in Chile to that in Costa Rica?
Offer a terse response. 3.68. What is the ratio of the Value added (constant 2005 US$) of 1961 in Chile to that in Costa Rica?
Your response must be concise. 3.48. What is the ratio of the Value added (constant 2005 US$) in 1962 in Chile to that in Costa Rica?
Offer a very short reply. 3.13. What is the ratio of the Value added (constant 2005 US$) of 1963 in Chile to that in Costa Rica?
Offer a terse response. 3.34. What is the ratio of the Value added (constant 2005 US$) of 1960 in Chile to that in France?
Provide a short and direct response. 0.07. What is the ratio of the Value added (constant 2005 US$) in 1961 in Chile to that in France?
Offer a very short reply. 0.07. What is the ratio of the Value added (constant 2005 US$) of 1962 in Chile to that in France?
Provide a short and direct response. 0.06. What is the ratio of the Value added (constant 2005 US$) of 1963 in Chile to that in France?
Offer a very short reply. 0.07. What is the ratio of the Value added (constant 2005 US$) of 1960 in Chile to that in Honduras?
Your answer should be compact. 3.77. What is the ratio of the Value added (constant 2005 US$) in 1961 in Chile to that in Honduras?
Give a very brief answer. 3.48. What is the ratio of the Value added (constant 2005 US$) of 1962 in Chile to that in Honduras?
Give a very brief answer. 3.17. What is the ratio of the Value added (constant 2005 US$) of 1963 in Chile to that in Honduras?
Ensure brevity in your answer.  3.25. What is the ratio of the Value added (constant 2005 US$) of 1960 in China to that in Congo (Republic)?
Keep it short and to the point. 403.12. What is the ratio of the Value added (constant 2005 US$) of 1961 in China to that in Congo (Republic)?
Your response must be concise. 423.9. What is the ratio of the Value added (constant 2005 US$) in 1962 in China to that in Congo (Republic)?
Your answer should be very brief. 440.32. What is the ratio of the Value added (constant 2005 US$) of 1963 in China to that in Congo (Republic)?
Ensure brevity in your answer.  486.68. What is the ratio of the Value added (constant 2005 US$) of 1960 in China to that in Costa Rica?
Provide a succinct answer. 130.03. What is the ratio of the Value added (constant 2005 US$) in 1961 in China to that in Costa Rica?
Provide a succinct answer. 127.18. What is the ratio of the Value added (constant 2005 US$) in 1962 in China to that in Costa Rica?
Provide a short and direct response. 125.23. What is the ratio of the Value added (constant 2005 US$) in 1963 in China to that in Costa Rica?
Your response must be concise. 139.78. What is the ratio of the Value added (constant 2005 US$) of 1960 in China to that in France?
Provide a short and direct response. 2.51. What is the ratio of the Value added (constant 2005 US$) in 1961 in China to that in France?
Provide a succinct answer. 2.69. What is the ratio of the Value added (constant 2005 US$) in 1962 in China to that in France?
Offer a very short reply. 2.58. What is the ratio of the Value added (constant 2005 US$) in 1963 in China to that in France?
Your answer should be very brief. 3.03. What is the ratio of the Value added (constant 2005 US$) in 1960 in China to that in Honduras?
Make the answer very short. 133.27. What is the ratio of the Value added (constant 2005 US$) in 1961 in China to that in Honduras?
Ensure brevity in your answer.  126.86. What is the ratio of the Value added (constant 2005 US$) of 1962 in China to that in Honduras?
Give a very brief answer. 126.55. What is the ratio of the Value added (constant 2005 US$) in 1963 in China to that in Honduras?
Provide a succinct answer. 135.91. What is the ratio of the Value added (constant 2005 US$) in 1960 in Congo (Republic) to that in Costa Rica?
Give a very brief answer. 0.32. What is the ratio of the Value added (constant 2005 US$) in 1962 in Congo (Republic) to that in Costa Rica?
Your response must be concise. 0.28. What is the ratio of the Value added (constant 2005 US$) in 1963 in Congo (Republic) to that in Costa Rica?
Your answer should be compact. 0.29. What is the ratio of the Value added (constant 2005 US$) in 1960 in Congo (Republic) to that in France?
Provide a short and direct response. 0.01. What is the ratio of the Value added (constant 2005 US$) of 1961 in Congo (Republic) to that in France?
Give a very brief answer. 0.01. What is the ratio of the Value added (constant 2005 US$) in 1962 in Congo (Republic) to that in France?
Keep it short and to the point. 0.01. What is the ratio of the Value added (constant 2005 US$) in 1963 in Congo (Republic) to that in France?
Offer a terse response. 0.01. What is the ratio of the Value added (constant 2005 US$) in 1960 in Congo (Republic) to that in Honduras?
Give a very brief answer. 0.33. What is the ratio of the Value added (constant 2005 US$) of 1961 in Congo (Republic) to that in Honduras?
Offer a terse response. 0.3. What is the ratio of the Value added (constant 2005 US$) in 1962 in Congo (Republic) to that in Honduras?
Offer a very short reply. 0.29. What is the ratio of the Value added (constant 2005 US$) in 1963 in Congo (Republic) to that in Honduras?
Give a very brief answer. 0.28. What is the ratio of the Value added (constant 2005 US$) in 1960 in Costa Rica to that in France?
Give a very brief answer. 0.02. What is the ratio of the Value added (constant 2005 US$) of 1961 in Costa Rica to that in France?
Make the answer very short. 0.02. What is the ratio of the Value added (constant 2005 US$) of 1962 in Costa Rica to that in France?
Give a very brief answer. 0.02. What is the ratio of the Value added (constant 2005 US$) in 1963 in Costa Rica to that in France?
Your answer should be compact. 0.02. What is the ratio of the Value added (constant 2005 US$) in 1960 in Costa Rica to that in Honduras?
Make the answer very short. 1.02. What is the ratio of the Value added (constant 2005 US$) of 1961 in Costa Rica to that in Honduras?
Make the answer very short. 1. What is the ratio of the Value added (constant 2005 US$) of 1962 in Costa Rica to that in Honduras?
Give a very brief answer. 1.01. What is the ratio of the Value added (constant 2005 US$) of 1963 in Costa Rica to that in Honduras?
Offer a terse response. 0.97. What is the ratio of the Value added (constant 2005 US$) in 1960 in France to that in Honduras?
Keep it short and to the point. 53.05. What is the ratio of the Value added (constant 2005 US$) in 1961 in France to that in Honduras?
Give a very brief answer. 47.21. What is the ratio of the Value added (constant 2005 US$) of 1962 in France to that in Honduras?
Your response must be concise. 49.07. What is the ratio of the Value added (constant 2005 US$) of 1963 in France to that in Honduras?
Offer a terse response. 44.92. What is the difference between the highest and the second highest Value added (constant 2005 US$) of 1960?
Make the answer very short. 2.45e+1. What is the difference between the highest and the second highest Value added (constant 2005 US$) of 1961?
Your answer should be very brief. 2.59e+1. What is the difference between the highest and the second highest Value added (constant 2005 US$) of 1962?
Keep it short and to the point. 2.64e+1. What is the difference between the highest and the second highest Value added (constant 2005 US$) of 1963?
Keep it short and to the point. 3.21e+1. What is the difference between the highest and the lowest Value added (constant 2005 US$) of 1960?
Ensure brevity in your answer.  4.06e+1. What is the difference between the highest and the lowest Value added (constant 2005 US$) in 1961?
Your answer should be very brief. 4.12e+1. What is the difference between the highest and the lowest Value added (constant 2005 US$) of 1962?
Ensure brevity in your answer.  4.30e+1. What is the difference between the highest and the lowest Value added (constant 2005 US$) of 1963?
Offer a terse response. 4.79e+1. 